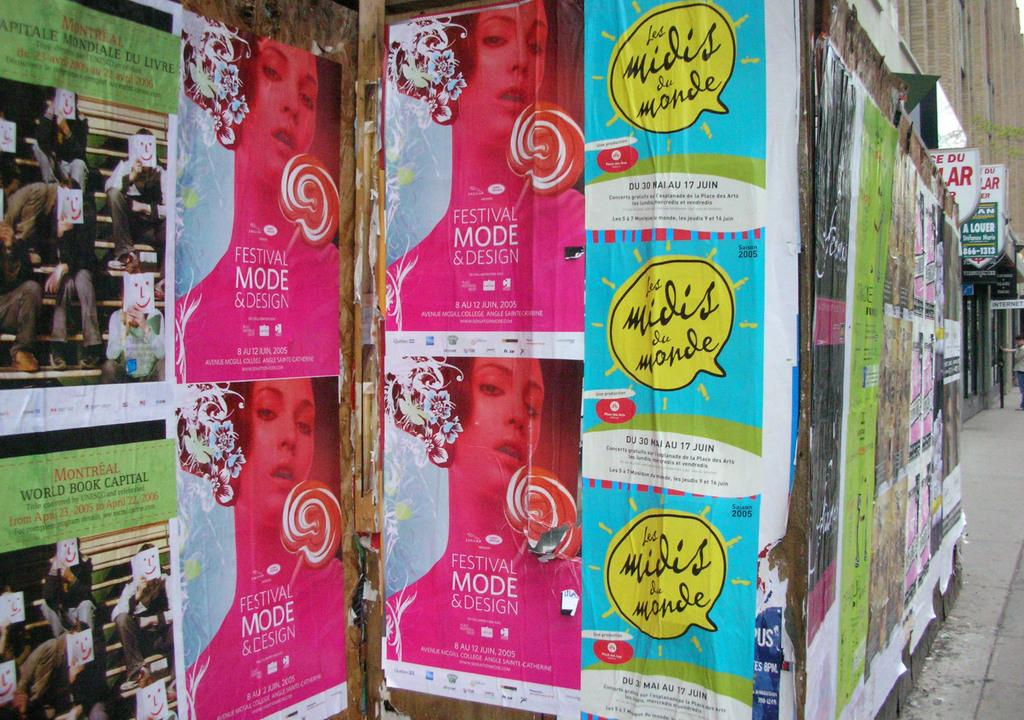Provide a one-sentence caption for the provided image. a wall of posters with one that says 'festival mode & design'. 